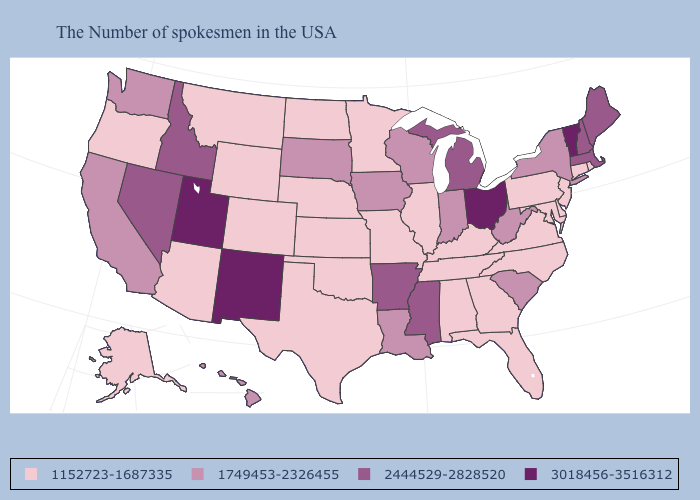Does Vermont have a higher value than Utah?
Quick response, please. No. What is the value of Nebraska?
Write a very short answer. 1152723-1687335. Does Rhode Island have the same value as Kentucky?
Short answer required. Yes. Does Kansas have the same value as Arkansas?
Keep it brief. No. Does Ohio have the highest value in the MidWest?
Concise answer only. Yes. What is the value of Oregon?
Quick response, please. 1152723-1687335. Which states hav the highest value in the South?
Give a very brief answer. Mississippi, Arkansas. What is the value of Ohio?
Quick response, please. 3018456-3516312. Name the states that have a value in the range 2444529-2828520?
Be succinct. Maine, Massachusetts, New Hampshire, Michigan, Mississippi, Arkansas, Idaho, Nevada. What is the value of New Jersey?
Quick response, please. 1152723-1687335. What is the highest value in states that border Ohio?
Give a very brief answer. 2444529-2828520. Which states hav the highest value in the West?
Short answer required. New Mexico, Utah. Does the first symbol in the legend represent the smallest category?
Answer briefly. Yes. What is the value of New York?
Quick response, please. 1749453-2326455. 